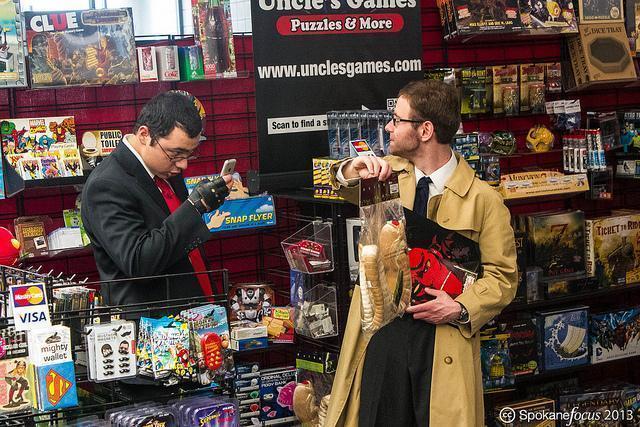What superhero's logo is printed on a wallet in front of the Visa sign?
Choose the correct response and explain in the format: 'Answer: answer
Rationale: rationale.'
Options: Wonder woman, green lantern, superman, batman. Answer: superman.
Rationale: The blue, red, and white s is well known to be the symbol for superman, as that appears on his cape. 